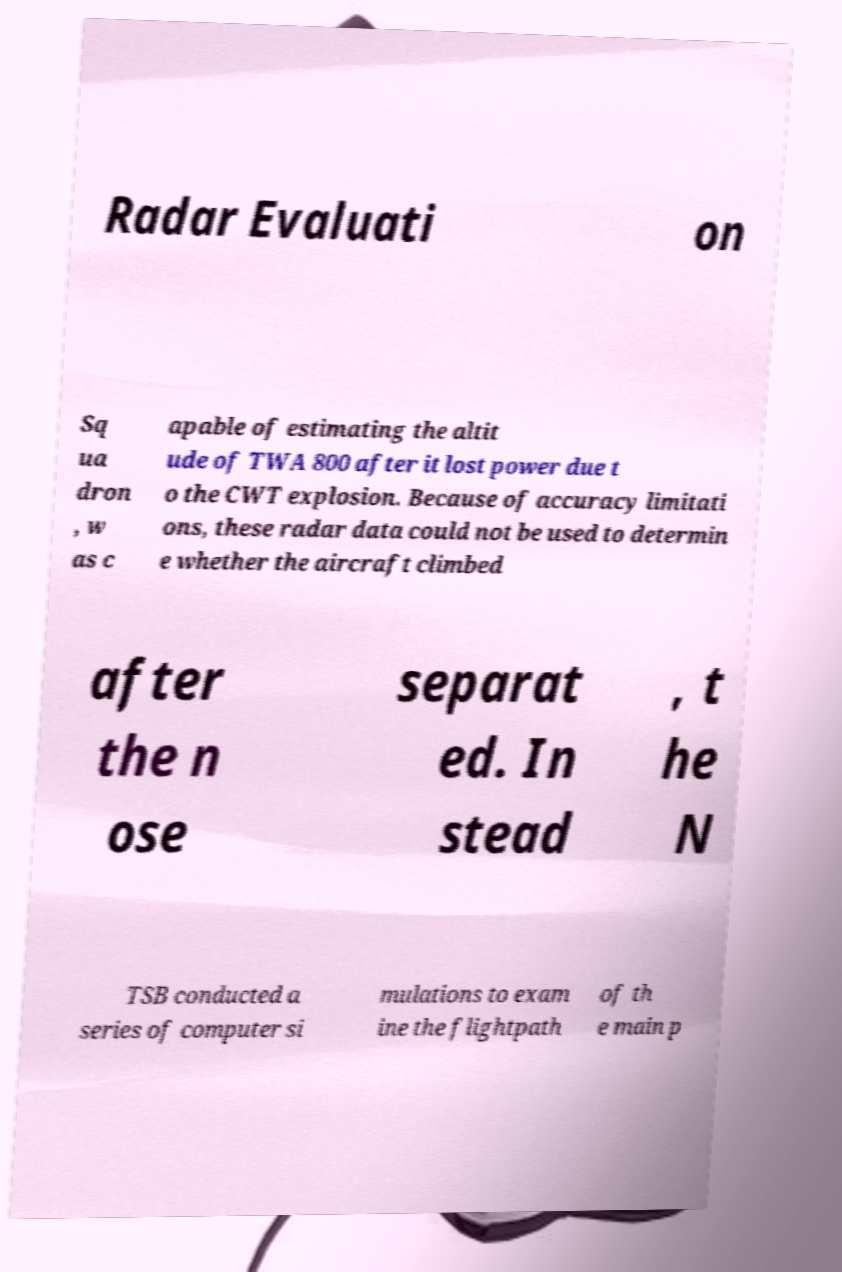For documentation purposes, I need the text within this image transcribed. Could you provide that? Radar Evaluati on Sq ua dron , w as c apable of estimating the altit ude of TWA 800 after it lost power due t o the CWT explosion. Because of accuracy limitati ons, these radar data could not be used to determin e whether the aircraft climbed after the n ose separat ed. In stead , t he N TSB conducted a series of computer si mulations to exam ine the flightpath of th e main p 